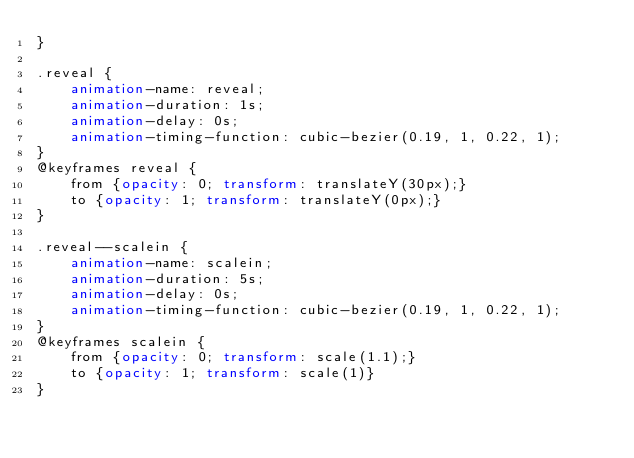Convert code to text. <code><loc_0><loc_0><loc_500><loc_500><_CSS_>}

.reveal {
	animation-name: reveal;
	animation-duration: 1s;
    animation-delay: 0s;
    animation-timing-function: cubic-bezier(0.19, 1, 0.22, 1);
}
@keyframes reveal {
    from {opacity: 0; transform: translateY(30px);}
    to {opacity: 1; transform: translateY(0px);}
}

.reveal--scalein {
    animation-name: scalein;
    animation-duration: 5s;
    animation-delay: 0s;
    animation-timing-function: cubic-bezier(0.19, 1, 0.22, 1);
}
@keyframes scalein {
	from {opacity: 0; transform: scale(1.1);}
	to {opacity: 1; transform: scale(1)}
}
</code> 